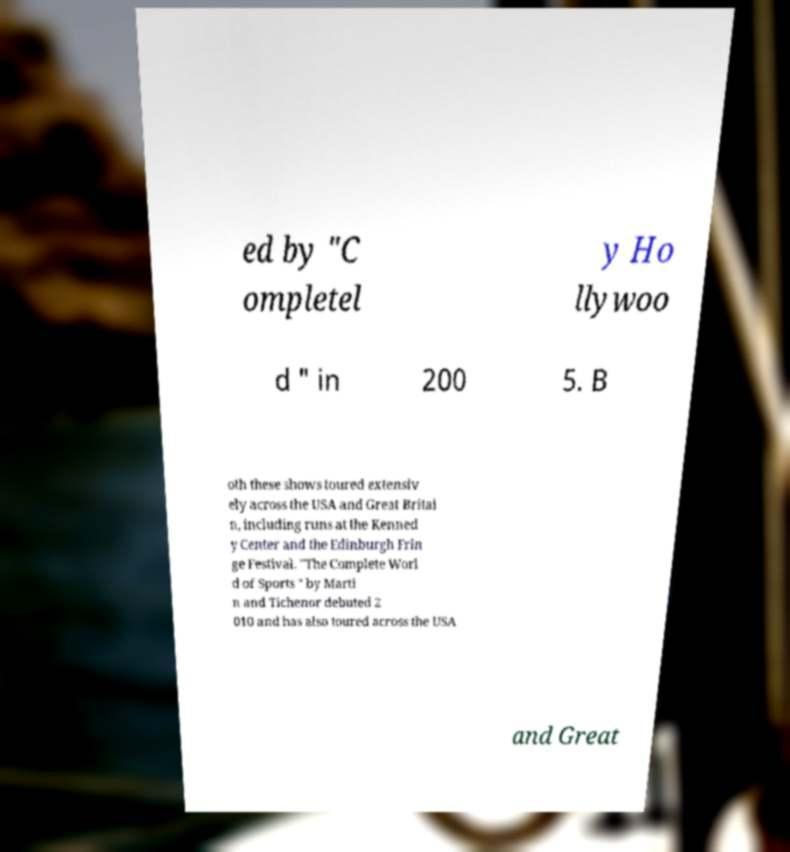Please read and relay the text visible in this image. What does it say? ed by "C ompletel y Ho llywoo d " in 200 5. B oth these shows toured extensiv ely across the USA and Great Britai n, including runs at the Kenned y Center and the Edinburgh Frin ge Festival. "The Complete Worl d of Sports " by Marti n and Tichenor debuted 2 010 and has also toured across the USA and Great 